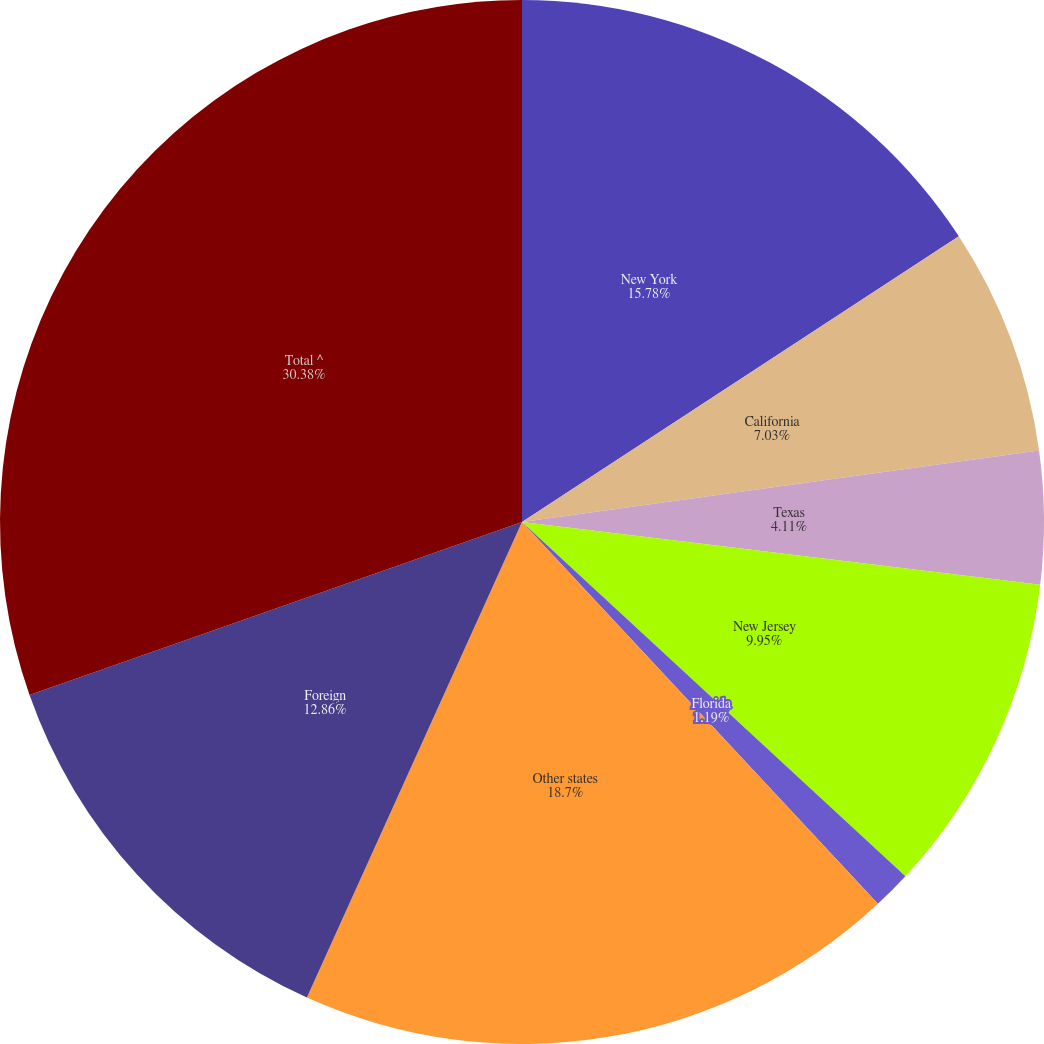Convert chart. <chart><loc_0><loc_0><loc_500><loc_500><pie_chart><fcel>New York<fcel>California<fcel>Texas<fcel>New Jersey<fcel>Florida<fcel>Other states<fcel>Foreign<fcel>Total ^<nl><fcel>15.78%<fcel>7.03%<fcel>4.11%<fcel>9.95%<fcel>1.19%<fcel>18.7%<fcel>12.86%<fcel>30.38%<nl></chart> 